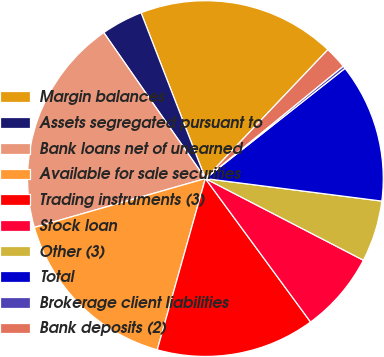Convert chart. <chart><loc_0><loc_0><loc_500><loc_500><pie_chart><fcel>Margin balances<fcel>Assets segregated pursuant to<fcel>Bank loans net of unearned<fcel>Available for sale securities<fcel>Trading instruments (3)<fcel>Stock loan<fcel>Other (3)<fcel>Total<fcel>Brokerage client liabilities<fcel>Bank deposits (2)<nl><fcel>17.98%<fcel>3.79%<fcel>19.75%<fcel>16.21%<fcel>14.43%<fcel>7.34%<fcel>5.57%<fcel>12.66%<fcel>0.25%<fcel>2.02%<nl></chart> 